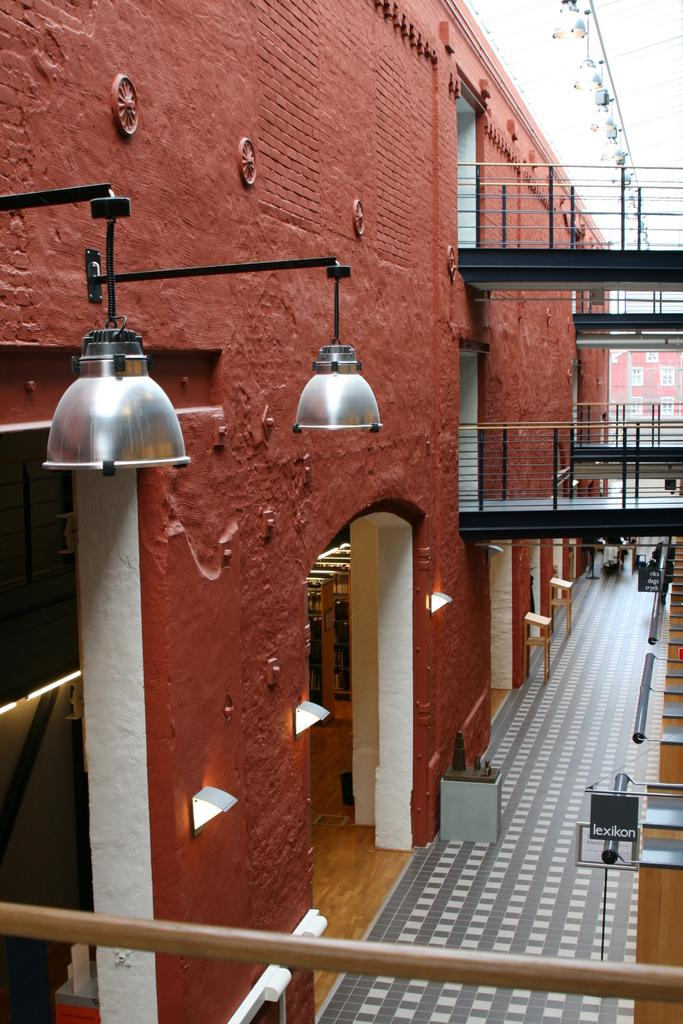What type of structure is present in the image? There is a building with railing in the image. What can be seen illuminated in the image? There are lights visible in the image. What is located on the right side of the image? There are boards on the right side of the image. What is visible in the background of the image? There is another building and the sky visible in the background of the image. Where is the map located in the image? There is no map present in the image. What type of balls can be seen in the image? There are no balls visible in the image. 